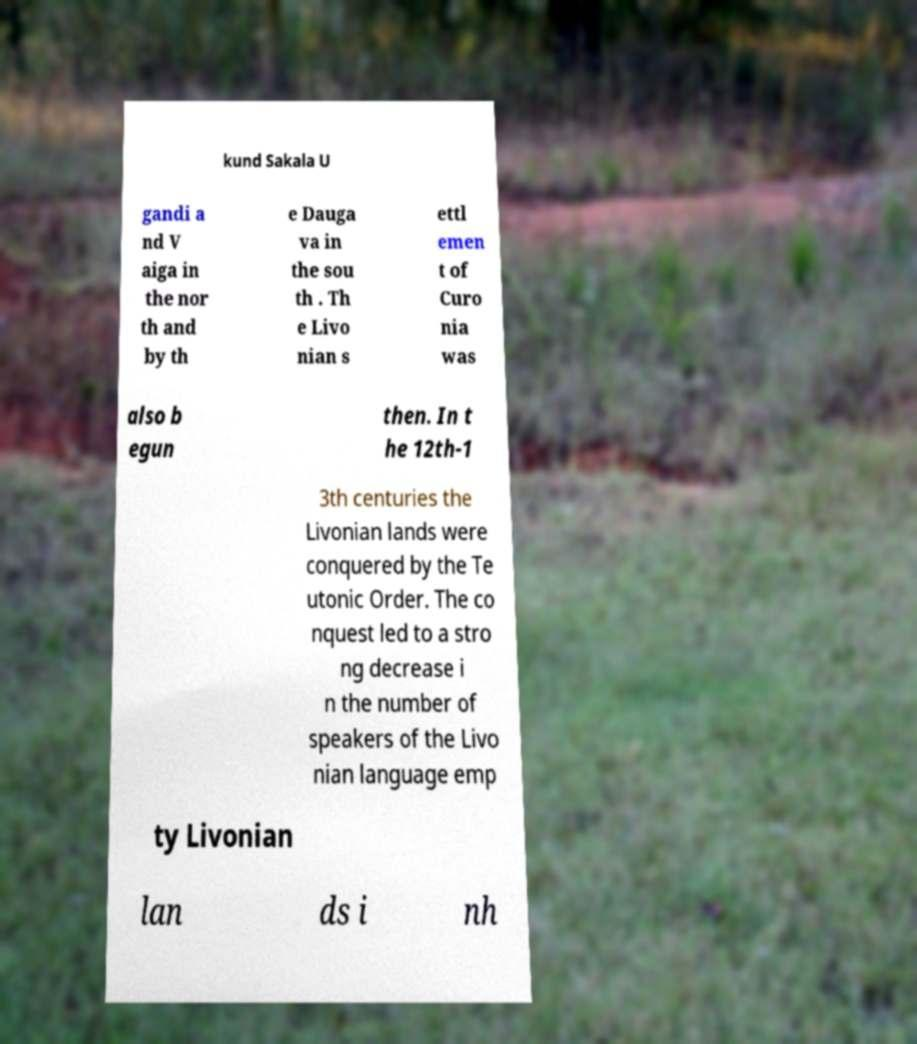Please read and relay the text visible in this image. What does it say? kund Sakala U gandi a nd V aiga in the nor th and by th e Dauga va in the sou th . Th e Livo nian s ettl emen t of Curo nia was also b egun then. In t he 12th-1 3th centuries the Livonian lands were conquered by the Te utonic Order. The co nquest led to a stro ng decrease i n the number of speakers of the Livo nian language emp ty Livonian lan ds i nh 